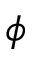<formula> <loc_0><loc_0><loc_500><loc_500>\phi</formula> 